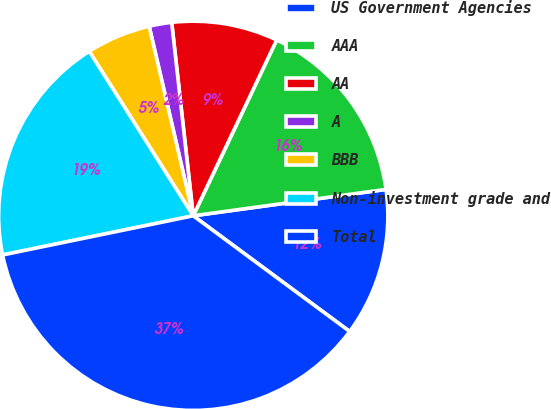<chart> <loc_0><loc_0><loc_500><loc_500><pie_chart><fcel>US Government Agencies<fcel>AAA<fcel>AA<fcel>A<fcel>BBB<fcel>Non-investment grade and<fcel>Total<nl><fcel>12.3%<fcel>15.78%<fcel>8.82%<fcel>1.87%<fcel>5.34%<fcel>19.25%<fcel>36.64%<nl></chart> 